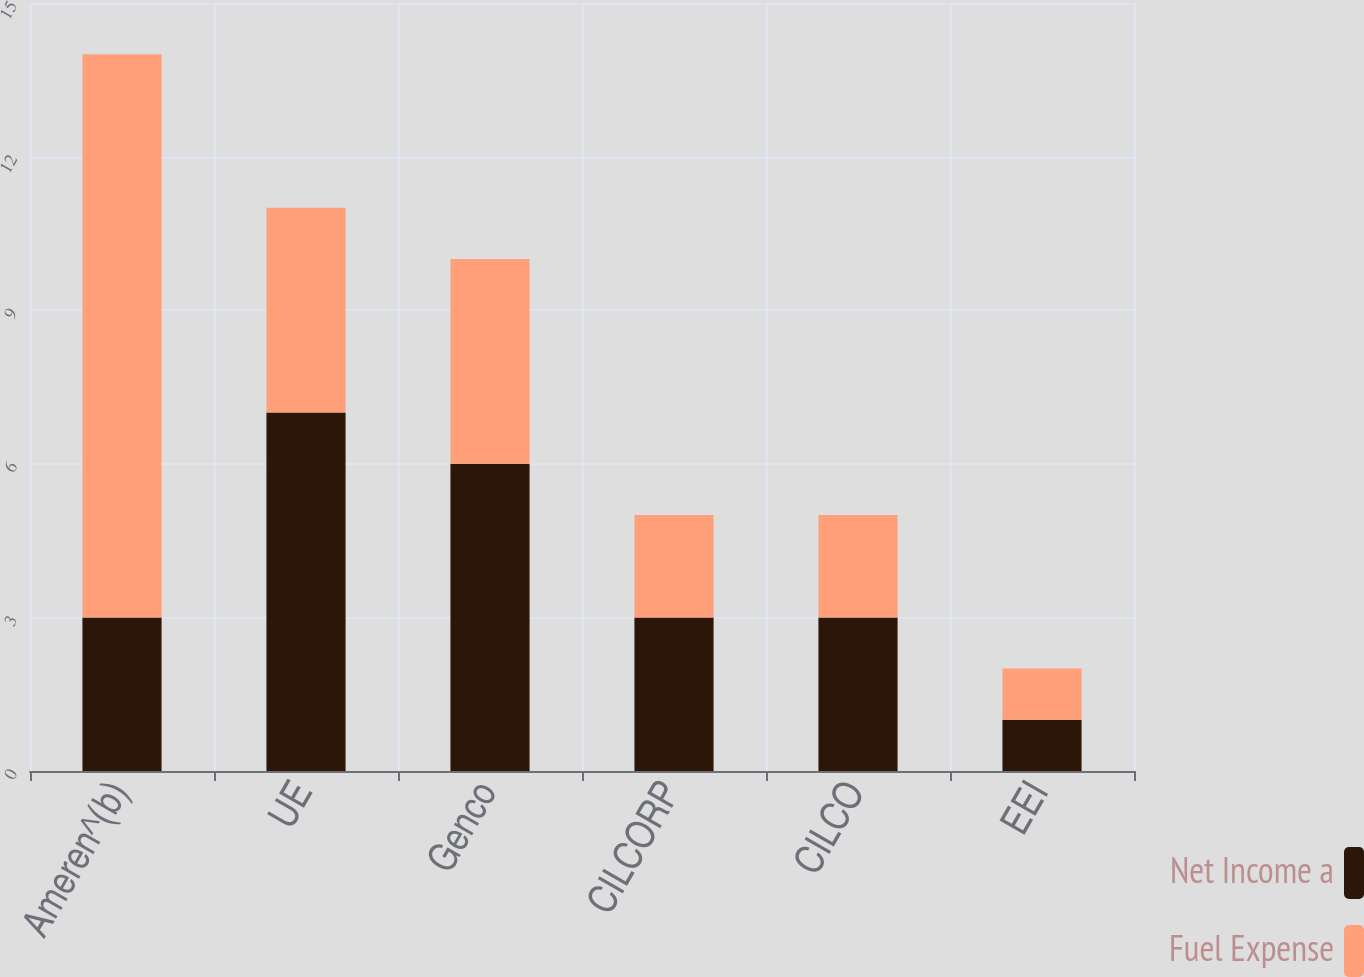<chart> <loc_0><loc_0><loc_500><loc_500><stacked_bar_chart><ecel><fcel>Ameren^(b)<fcel>UE<fcel>Genco<fcel>CILCORP<fcel>CILCO<fcel>EEI<nl><fcel>Net Income a<fcel>3<fcel>7<fcel>6<fcel>3<fcel>3<fcel>1<nl><fcel>Fuel Expense<fcel>11<fcel>4<fcel>4<fcel>2<fcel>2<fcel>1<nl></chart> 